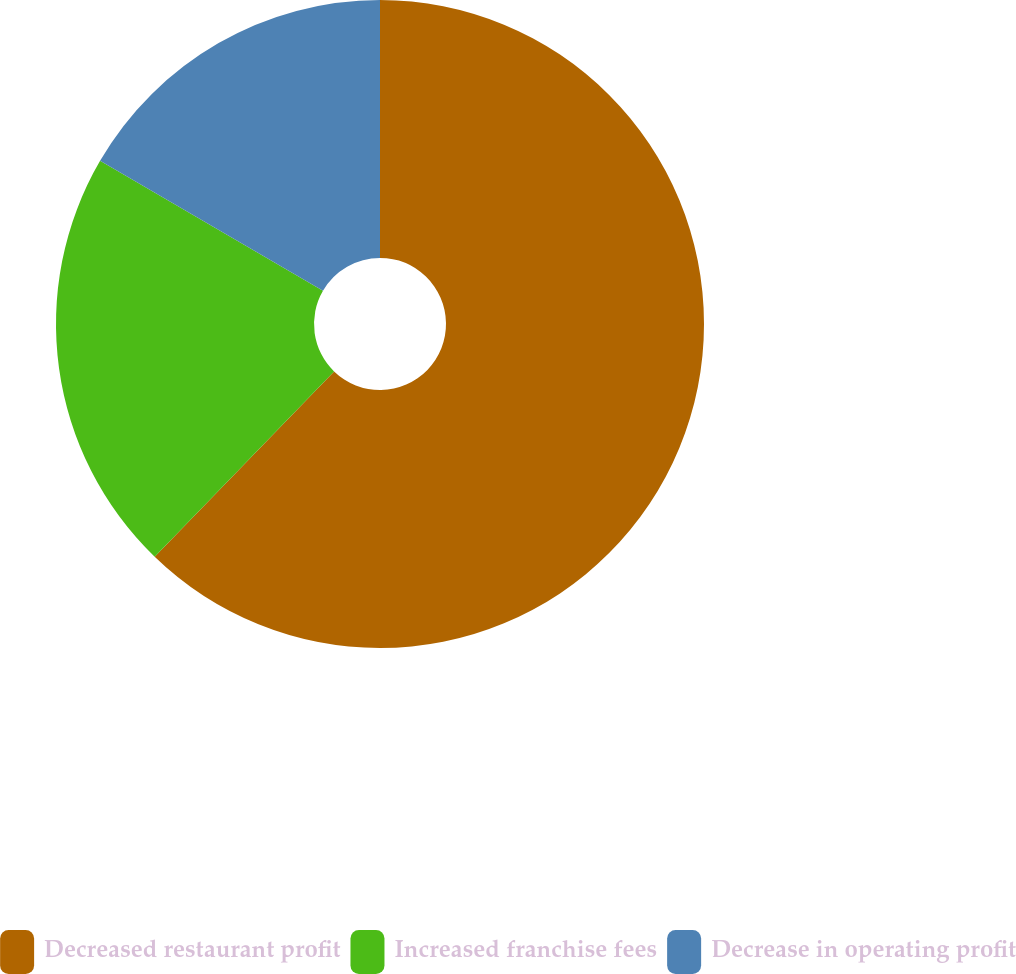Convert chart to OTSL. <chart><loc_0><loc_0><loc_500><loc_500><pie_chart><fcel>Decreased restaurant profit<fcel>Increased franchise fees<fcel>Decrease in operating profit<nl><fcel>62.24%<fcel>21.16%<fcel>16.6%<nl></chart> 